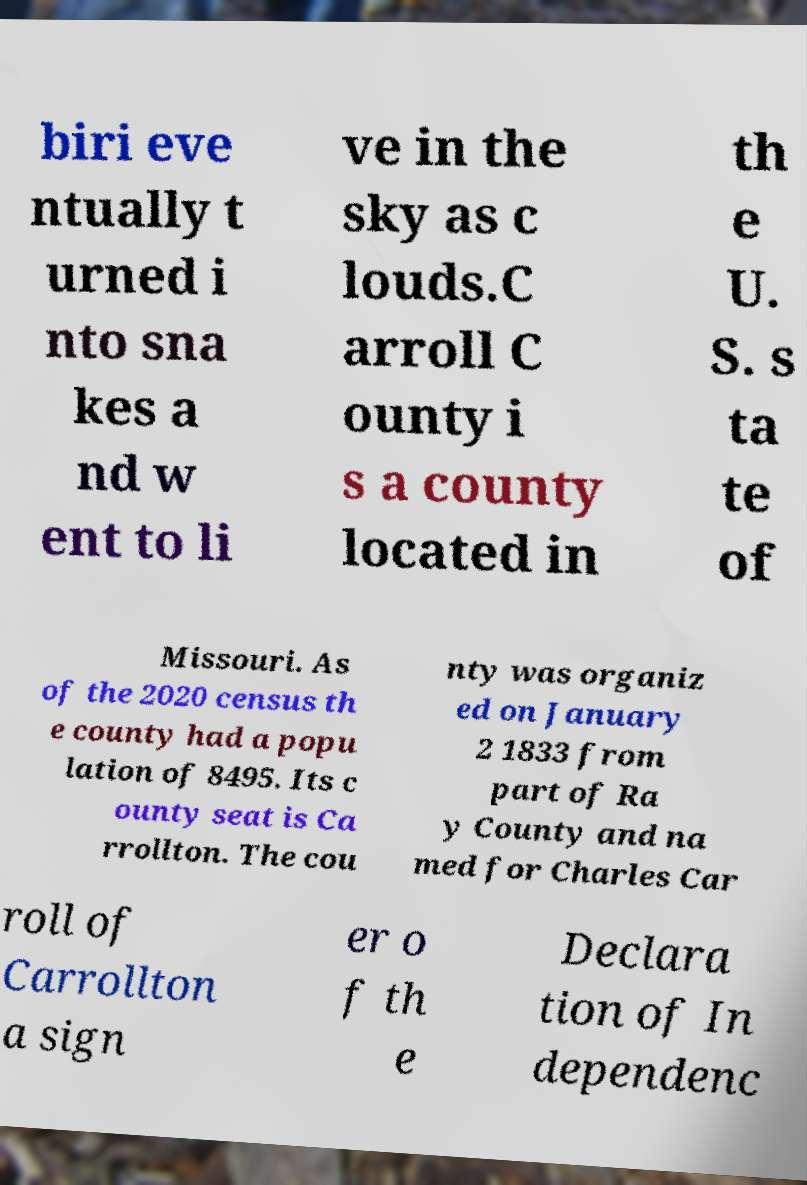Please identify and transcribe the text found in this image. biri eve ntually t urned i nto sna kes a nd w ent to li ve in the sky as c louds.C arroll C ounty i s a county located in th e U. S. s ta te of Missouri. As of the 2020 census th e county had a popu lation of 8495. Its c ounty seat is Ca rrollton. The cou nty was organiz ed on January 2 1833 from part of Ra y County and na med for Charles Car roll of Carrollton a sign er o f th e Declara tion of In dependenc 